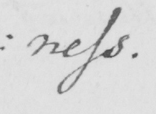What is written in this line of handwriting? : ness . 